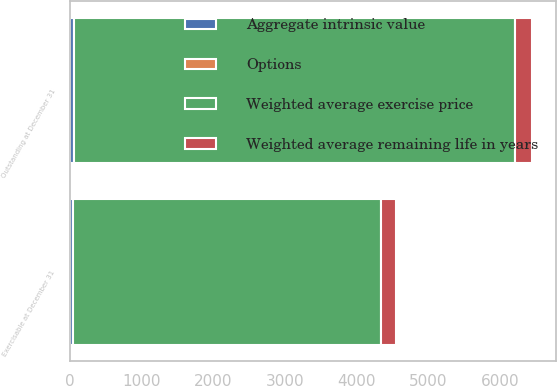<chart> <loc_0><loc_0><loc_500><loc_500><stacked_bar_chart><ecel><fcel>Outstanding at December 31<fcel>Exercisable at December 31<nl><fcel>Weighted average exercise price<fcel>6143<fcel>4293<nl><fcel>Aggregate intrinsic value<fcel>55.05<fcel>45.23<nl><fcel>Options<fcel>6.2<fcel>5.3<nl><fcel>Weighted average remaining life in years<fcel>242<fcel>202<nl></chart> 